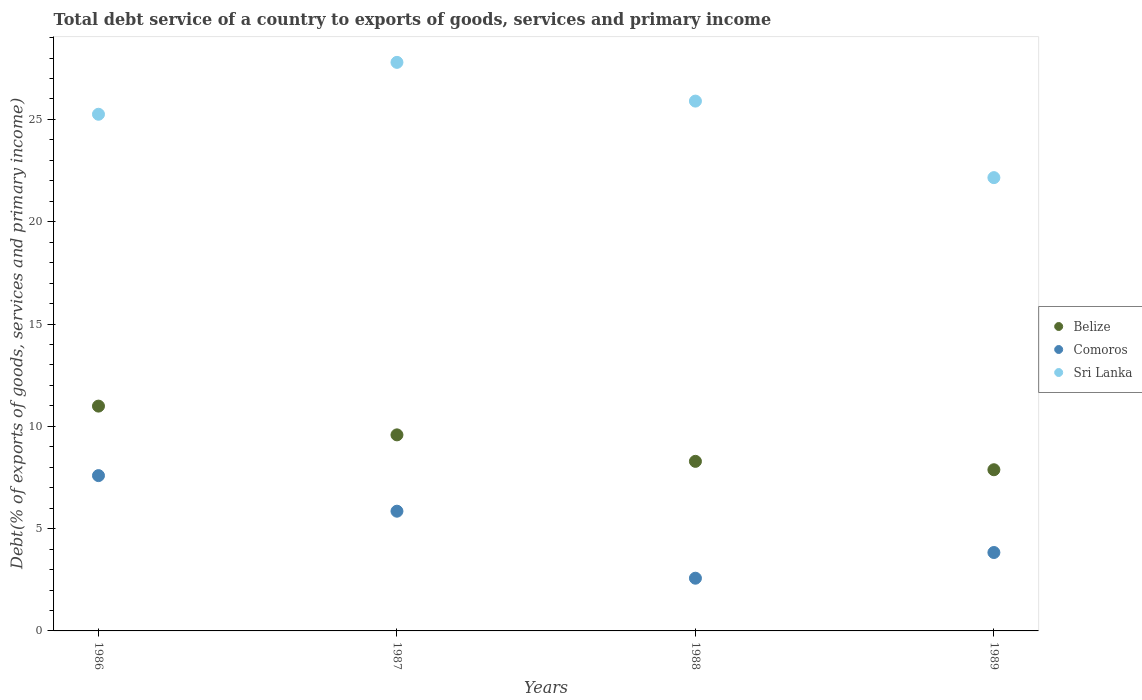How many different coloured dotlines are there?
Your answer should be compact. 3. Is the number of dotlines equal to the number of legend labels?
Give a very brief answer. Yes. What is the total debt service in Comoros in 1988?
Keep it short and to the point. 2.58. Across all years, what is the maximum total debt service in Comoros?
Keep it short and to the point. 7.59. Across all years, what is the minimum total debt service in Belize?
Provide a succinct answer. 7.88. In which year was the total debt service in Sri Lanka minimum?
Offer a very short reply. 1989. What is the total total debt service in Belize in the graph?
Your answer should be compact. 36.74. What is the difference between the total debt service in Sri Lanka in 1986 and that in 1988?
Offer a very short reply. -0.64. What is the difference between the total debt service in Sri Lanka in 1989 and the total debt service in Comoros in 1987?
Offer a very short reply. 16.3. What is the average total debt service in Sri Lanka per year?
Keep it short and to the point. 25.27. In the year 1988, what is the difference between the total debt service in Comoros and total debt service in Sri Lanka?
Ensure brevity in your answer.  -23.32. In how many years, is the total debt service in Sri Lanka greater than 26 %?
Make the answer very short. 1. What is the ratio of the total debt service in Belize in 1987 to that in 1988?
Give a very brief answer. 1.16. What is the difference between the highest and the second highest total debt service in Sri Lanka?
Your response must be concise. 1.89. What is the difference between the highest and the lowest total debt service in Comoros?
Give a very brief answer. 5.01. In how many years, is the total debt service in Comoros greater than the average total debt service in Comoros taken over all years?
Your answer should be compact. 2. Is the sum of the total debt service in Sri Lanka in 1988 and 1989 greater than the maximum total debt service in Comoros across all years?
Offer a very short reply. Yes. Does the total debt service in Comoros monotonically increase over the years?
Make the answer very short. No. How many dotlines are there?
Give a very brief answer. 3. Does the graph contain any zero values?
Give a very brief answer. No. Does the graph contain grids?
Ensure brevity in your answer.  No. Where does the legend appear in the graph?
Keep it short and to the point. Center right. How many legend labels are there?
Provide a succinct answer. 3. What is the title of the graph?
Offer a very short reply. Total debt service of a country to exports of goods, services and primary income. Does "United Arab Emirates" appear as one of the legend labels in the graph?
Offer a very short reply. No. What is the label or title of the X-axis?
Keep it short and to the point. Years. What is the label or title of the Y-axis?
Your answer should be very brief. Debt(% of exports of goods, services and primary income). What is the Debt(% of exports of goods, services and primary income) of Belize in 1986?
Offer a terse response. 10.99. What is the Debt(% of exports of goods, services and primary income) of Comoros in 1986?
Make the answer very short. 7.59. What is the Debt(% of exports of goods, services and primary income) in Sri Lanka in 1986?
Provide a short and direct response. 25.25. What is the Debt(% of exports of goods, services and primary income) in Belize in 1987?
Offer a very short reply. 9.58. What is the Debt(% of exports of goods, services and primary income) of Comoros in 1987?
Provide a short and direct response. 5.85. What is the Debt(% of exports of goods, services and primary income) of Sri Lanka in 1987?
Give a very brief answer. 27.79. What is the Debt(% of exports of goods, services and primary income) in Belize in 1988?
Your response must be concise. 8.29. What is the Debt(% of exports of goods, services and primary income) in Comoros in 1988?
Offer a terse response. 2.58. What is the Debt(% of exports of goods, services and primary income) in Sri Lanka in 1988?
Your response must be concise. 25.9. What is the Debt(% of exports of goods, services and primary income) of Belize in 1989?
Your response must be concise. 7.88. What is the Debt(% of exports of goods, services and primary income) in Comoros in 1989?
Make the answer very short. 3.83. What is the Debt(% of exports of goods, services and primary income) of Sri Lanka in 1989?
Ensure brevity in your answer.  22.16. Across all years, what is the maximum Debt(% of exports of goods, services and primary income) in Belize?
Give a very brief answer. 10.99. Across all years, what is the maximum Debt(% of exports of goods, services and primary income) of Comoros?
Offer a terse response. 7.59. Across all years, what is the maximum Debt(% of exports of goods, services and primary income) of Sri Lanka?
Your answer should be compact. 27.79. Across all years, what is the minimum Debt(% of exports of goods, services and primary income) in Belize?
Make the answer very short. 7.88. Across all years, what is the minimum Debt(% of exports of goods, services and primary income) in Comoros?
Give a very brief answer. 2.58. Across all years, what is the minimum Debt(% of exports of goods, services and primary income) in Sri Lanka?
Make the answer very short. 22.16. What is the total Debt(% of exports of goods, services and primary income) in Belize in the graph?
Provide a succinct answer. 36.74. What is the total Debt(% of exports of goods, services and primary income) in Comoros in the graph?
Ensure brevity in your answer.  19.85. What is the total Debt(% of exports of goods, services and primary income) in Sri Lanka in the graph?
Give a very brief answer. 101.1. What is the difference between the Debt(% of exports of goods, services and primary income) of Belize in 1986 and that in 1987?
Your answer should be compact. 1.41. What is the difference between the Debt(% of exports of goods, services and primary income) in Comoros in 1986 and that in 1987?
Your answer should be very brief. 1.74. What is the difference between the Debt(% of exports of goods, services and primary income) of Sri Lanka in 1986 and that in 1987?
Ensure brevity in your answer.  -2.54. What is the difference between the Debt(% of exports of goods, services and primary income) of Belize in 1986 and that in 1988?
Provide a succinct answer. 2.7. What is the difference between the Debt(% of exports of goods, services and primary income) in Comoros in 1986 and that in 1988?
Provide a short and direct response. 5.01. What is the difference between the Debt(% of exports of goods, services and primary income) of Sri Lanka in 1986 and that in 1988?
Keep it short and to the point. -0.64. What is the difference between the Debt(% of exports of goods, services and primary income) in Belize in 1986 and that in 1989?
Ensure brevity in your answer.  3.11. What is the difference between the Debt(% of exports of goods, services and primary income) in Comoros in 1986 and that in 1989?
Your response must be concise. 3.76. What is the difference between the Debt(% of exports of goods, services and primary income) in Sri Lanka in 1986 and that in 1989?
Your response must be concise. 3.1. What is the difference between the Debt(% of exports of goods, services and primary income) of Belize in 1987 and that in 1988?
Your answer should be compact. 1.29. What is the difference between the Debt(% of exports of goods, services and primary income) of Comoros in 1987 and that in 1988?
Offer a very short reply. 3.28. What is the difference between the Debt(% of exports of goods, services and primary income) of Sri Lanka in 1987 and that in 1988?
Provide a succinct answer. 1.89. What is the difference between the Debt(% of exports of goods, services and primary income) in Belize in 1987 and that in 1989?
Ensure brevity in your answer.  1.7. What is the difference between the Debt(% of exports of goods, services and primary income) of Comoros in 1987 and that in 1989?
Your answer should be compact. 2.02. What is the difference between the Debt(% of exports of goods, services and primary income) in Sri Lanka in 1987 and that in 1989?
Your answer should be compact. 5.63. What is the difference between the Debt(% of exports of goods, services and primary income) of Belize in 1988 and that in 1989?
Offer a very short reply. 0.41. What is the difference between the Debt(% of exports of goods, services and primary income) in Comoros in 1988 and that in 1989?
Offer a terse response. -1.26. What is the difference between the Debt(% of exports of goods, services and primary income) of Sri Lanka in 1988 and that in 1989?
Your answer should be very brief. 3.74. What is the difference between the Debt(% of exports of goods, services and primary income) of Belize in 1986 and the Debt(% of exports of goods, services and primary income) of Comoros in 1987?
Ensure brevity in your answer.  5.14. What is the difference between the Debt(% of exports of goods, services and primary income) of Belize in 1986 and the Debt(% of exports of goods, services and primary income) of Sri Lanka in 1987?
Give a very brief answer. -16.8. What is the difference between the Debt(% of exports of goods, services and primary income) in Comoros in 1986 and the Debt(% of exports of goods, services and primary income) in Sri Lanka in 1987?
Provide a short and direct response. -20.2. What is the difference between the Debt(% of exports of goods, services and primary income) of Belize in 1986 and the Debt(% of exports of goods, services and primary income) of Comoros in 1988?
Keep it short and to the point. 8.41. What is the difference between the Debt(% of exports of goods, services and primary income) in Belize in 1986 and the Debt(% of exports of goods, services and primary income) in Sri Lanka in 1988?
Offer a very short reply. -14.91. What is the difference between the Debt(% of exports of goods, services and primary income) in Comoros in 1986 and the Debt(% of exports of goods, services and primary income) in Sri Lanka in 1988?
Offer a very short reply. -18.31. What is the difference between the Debt(% of exports of goods, services and primary income) in Belize in 1986 and the Debt(% of exports of goods, services and primary income) in Comoros in 1989?
Provide a short and direct response. 7.16. What is the difference between the Debt(% of exports of goods, services and primary income) in Belize in 1986 and the Debt(% of exports of goods, services and primary income) in Sri Lanka in 1989?
Keep it short and to the point. -11.17. What is the difference between the Debt(% of exports of goods, services and primary income) in Comoros in 1986 and the Debt(% of exports of goods, services and primary income) in Sri Lanka in 1989?
Your response must be concise. -14.56. What is the difference between the Debt(% of exports of goods, services and primary income) of Belize in 1987 and the Debt(% of exports of goods, services and primary income) of Comoros in 1988?
Offer a terse response. 7.01. What is the difference between the Debt(% of exports of goods, services and primary income) of Belize in 1987 and the Debt(% of exports of goods, services and primary income) of Sri Lanka in 1988?
Your answer should be compact. -16.31. What is the difference between the Debt(% of exports of goods, services and primary income) in Comoros in 1987 and the Debt(% of exports of goods, services and primary income) in Sri Lanka in 1988?
Provide a succinct answer. -20.04. What is the difference between the Debt(% of exports of goods, services and primary income) in Belize in 1987 and the Debt(% of exports of goods, services and primary income) in Comoros in 1989?
Make the answer very short. 5.75. What is the difference between the Debt(% of exports of goods, services and primary income) of Belize in 1987 and the Debt(% of exports of goods, services and primary income) of Sri Lanka in 1989?
Offer a very short reply. -12.57. What is the difference between the Debt(% of exports of goods, services and primary income) in Comoros in 1987 and the Debt(% of exports of goods, services and primary income) in Sri Lanka in 1989?
Give a very brief answer. -16.3. What is the difference between the Debt(% of exports of goods, services and primary income) in Belize in 1988 and the Debt(% of exports of goods, services and primary income) in Comoros in 1989?
Your answer should be very brief. 4.46. What is the difference between the Debt(% of exports of goods, services and primary income) in Belize in 1988 and the Debt(% of exports of goods, services and primary income) in Sri Lanka in 1989?
Provide a short and direct response. -13.87. What is the difference between the Debt(% of exports of goods, services and primary income) of Comoros in 1988 and the Debt(% of exports of goods, services and primary income) of Sri Lanka in 1989?
Make the answer very short. -19.58. What is the average Debt(% of exports of goods, services and primary income) in Belize per year?
Your answer should be compact. 9.18. What is the average Debt(% of exports of goods, services and primary income) in Comoros per year?
Your response must be concise. 4.96. What is the average Debt(% of exports of goods, services and primary income) of Sri Lanka per year?
Offer a very short reply. 25.27. In the year 1986, what is the difference between the Debt(% of exports of goods, services and primary income) of Belize and Debt(% of exports of goods, services and primary income) of Comoros?
Your answer should be very brief. 3.4. In the year 1986, what is the difference between the Debt(% of exports of goods, services and primary income) of Belize and Debt(% of exports of goods, services and primary income) of Sri Lanka?
Your answer should be compact. -14.27. In the year 1986, what is the difference between the Debt(% of exports of goods, services and primary income) of Comoros and Debt(% of exports of goods, services and primary income) of Sri Lanka?
Your response must be concise. -17.66. In the year 1987, what is the difference between the Debt(% of exports of goods, services and primary income) of Belize and Debt(% of exports of goods, services and primary income) of Comoros?
Your response must be concise. 3.73. In the year 1987, what is the difference between the Debt(% of exports of goods, services and primary income) in Belize and Debt(% of exports of goods, services and primary income) in Sri Lanka?
Your response must be concise. -18.21. In the year 1987, what is the difference between the Debt(% of exports of goods, services and primary income) in Comoros and Debt(% of exports of goods, services and primary income) in Sri Lanka?
Offer a very short reply. -21.94. In the year 1988, what is the difference between the Debt(% of exports of goods, services and primary income) in Belize and Debt(% of exports of goods, services and primary income) in Comoros?
Your answer should be very brief. 5.71. In the year 1988, what is the difference between the Debt(% of exports of goods, services and primary income) of Belize and Debt(% of exports of goods, services and primary income) of Sri Lanka?
Keep it short and to the point. -17.61. In the year 1988, what is the difference between the Debt(% of exports of goods, services and primary income) of Comoros and Debt(% of exports of goods, services and primary income) of Sri Lanka?
Provide a succinct answer. -23.32. In the year 1989, what is the difference between the Debt(% of exports of goods, services and primary income) in Belize and Debt(% of exports of goods, services and primary income) in Comoros?
Provide a succinct answer. 4.05. In the year 1989, what is the difference between the Debt(% of exports of goods, services and primary income) in Belize and Debt(% of exports of goods, services and primary income) in Sri Lanka?
Provide a short and direct response. -14.28. In the year 1989, what is the difference between the Debt(% of exports of goods, services and primary income) of Comoros and Debt(% of exports of goods, services and primary income) of Sri Lanka?
Make the answer very short. -18.32. What is the ratio of the Debt(% of exports of goods, services and primary income) of Belize in 1986 to that in 1987?
Offer a terse response. 1.15. What is the ratio of the Debt(% of exports of goods, services and primary income) of Comoros in 1986 to that in 1987?
Keep it short and to the point. 1.3. What is the ratio of the Debt(% of exports of goods, services and primary income) in Sri Lanka in 1986 to that in 1987?
Give a very brief answer. 0.91. What is the ratio of the Debt(% of exports of goods, services and primary income) in Belize in 1986 to that in 1988?
Keep it short and to the point. 1.33. What is the ratio of the Debt(% of exports of goods, services and primary income) of Comoros in 1986 to that in 1988?
Give a very brief answer. 2.95. What is the ratio of the Debt(% of exports of goods, services and primary income) in Sri Lanka in 1986 to that in 1988?
Your answer should be very brief. 0.98. What is the ratio of the Debt(% of exports of goods, services and primary income) in Belize in 1986 to that in 1989?
Offer a very short reply. 1.39. What is the ratio of the Debt(% of exports of goods, services and primary income) in Comoros in 1986 to that in 1989?
Provide a succinct answer. 1.98. What is the ratio of the Debt(% of exports of goods, services and primary income) of Sri Lanka in 1986 to that in 1989?
Provide a succinct answer. 1.14. What is the ratio of the Debt(% of exports of goods, services and primary income) of Belize in 1987 to that in 1988?
Your response must be concise. 1.16. What is the ratio of the Debt(% of exports of goods, services and primary income) in Comoros in 1987 to that in 1988?
Keep it short and to the point. 2.27. What is the ratio of the Debt(% of exports of goods, services and primary income) in Sri Lanka in 1987 to that in 1988?
Your response must be concise. 1.07. What is the ratio of the Debt(% of exports of goods, services and primary income) in Belize in 1987 to that in 1989?
Offer a terse response. 1.22. What is the ratio of the Debt(% of exports of goods, services and primary income) of Comoros in 1987 to that in 1989?
Offer a terse response. 1.53. What is the ratio of the Debt(% of exports of goods, services and primary income) in Sri Lanka in 1987 to that in 1989?
Your answer should be compact. 1.25. What is the ratio of the Debt(% of exports of goods, services and primary income) in Belize in 1988 to that in 1989?
Provide a succinct answer. 1.05. What is the ratio of the Debt(% of exports of goods, services and primary income) in Comoros in 1988 to that in 1989?
Make the answer very short. 0.67. What is the ratio of the Debt(% of exports of goods, services and primary income) in Sri Lanka in 1988 to that in 1989?
Give a very brief answer. 1.17. What is the difference between the highest and the second highest Debt(% of exports of goods, services and primary income) in Belize?
Offer a terse response. 1.41. What is the difference between the highest and the second highest Debt(% of exports of goods, services and primary income) in Comoros?
Provide a short and direct response. 1.74. What is the difference between the highest and the second highest Debt(% of exports of goods, services and primary income) in Sri Lanka?
Offer a terse response. 1.89. What is the difference between the highest and the lowest Debt(% of exports of goods, services and primary income) of Belize?
Ensure brevity in your answer.  3.11. What is the difference between the highest and the lowest Debt(% of exports of goods, services and primary income) in Comoros?
Keep it short and to the point. 5.01. What is the difference between the highest and the lowest Debt(% of exports of goods, services and primary income) in Sri Lanka?
Give a very brief answer. 5.63. 